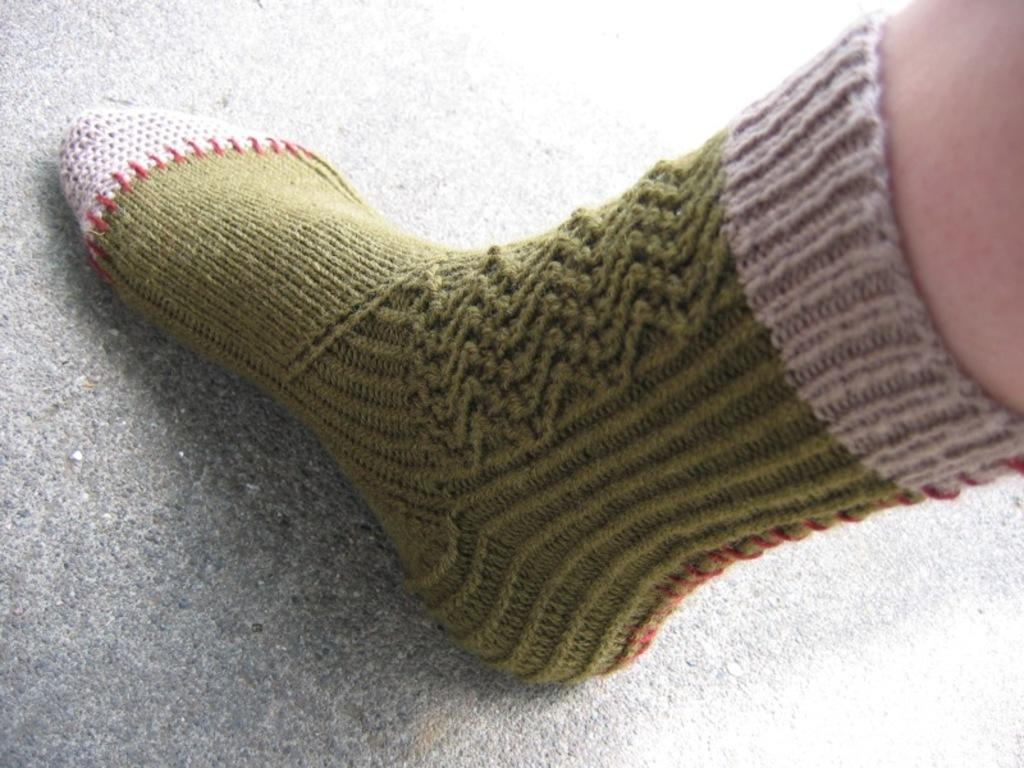What is present in the image? There is a person in the image. Can you describe the person's attire? The person is wearing a sock. What type of mist can be seen surrounding the person in the image? There is no mist present in the image; it only shows a person wearing a sock. 